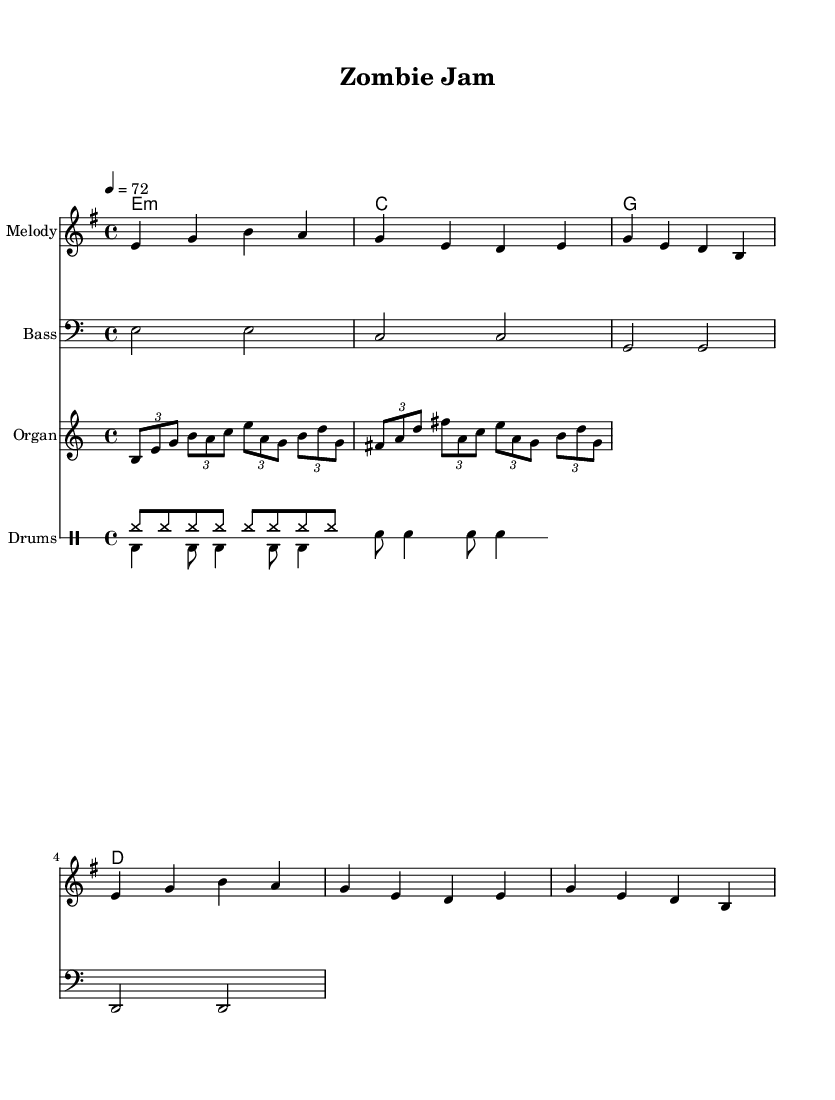What is the key signature of this music? The key signature indicated at the beginning of the score shows one sharp, which corresponds to E minor.
Answer: E minor What is the time signature? The time signature is shown at the beginning of the score as 4/4, meaning there are four beats in each measure.
Answer: 4/4 What is the tempo marking for this piece? The tempo marking indicates the piece should be played at a speed of 72 beats per minute. This is shown as a number next to the tempo directive.
Answer: 72 How many measures does the melody contain? Counting the measures in the melody section, there are a total of 8 measures present in the notation.
Answer: 8 What type of drum pattern is present in this piece? The score indicates two distinct drum patterns: an upbeat pattern and a downbeat pattern, typical in reggae music. The upbeat pattern features hi-hats, while the downbeat pattern mixes bass and snare drums.
Answer: Upbeat and downbeat What chord progression is used throughout the piece? The harmony section outlines a specific chord progression: E minor, C major, G major, D major, which depicts a common reggae style.
Answer: E minor, C major, G major, D major Is there a specific instrument that plays the organ riff? The organ riff is noted in the score under a dedicated staff labeled "Organ," which identifies the instrument responsible for that particular musical line.
Answer: Organ 